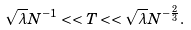Convert formula to latex. <formula><loc_0><loc_0><loc_500><loc_500>\sqrt { \lambda } N ^ { - 1 } < < T < < \sqrt { \lambda } N ^ { - \frac { 2 } { 3 } } .</formula> 